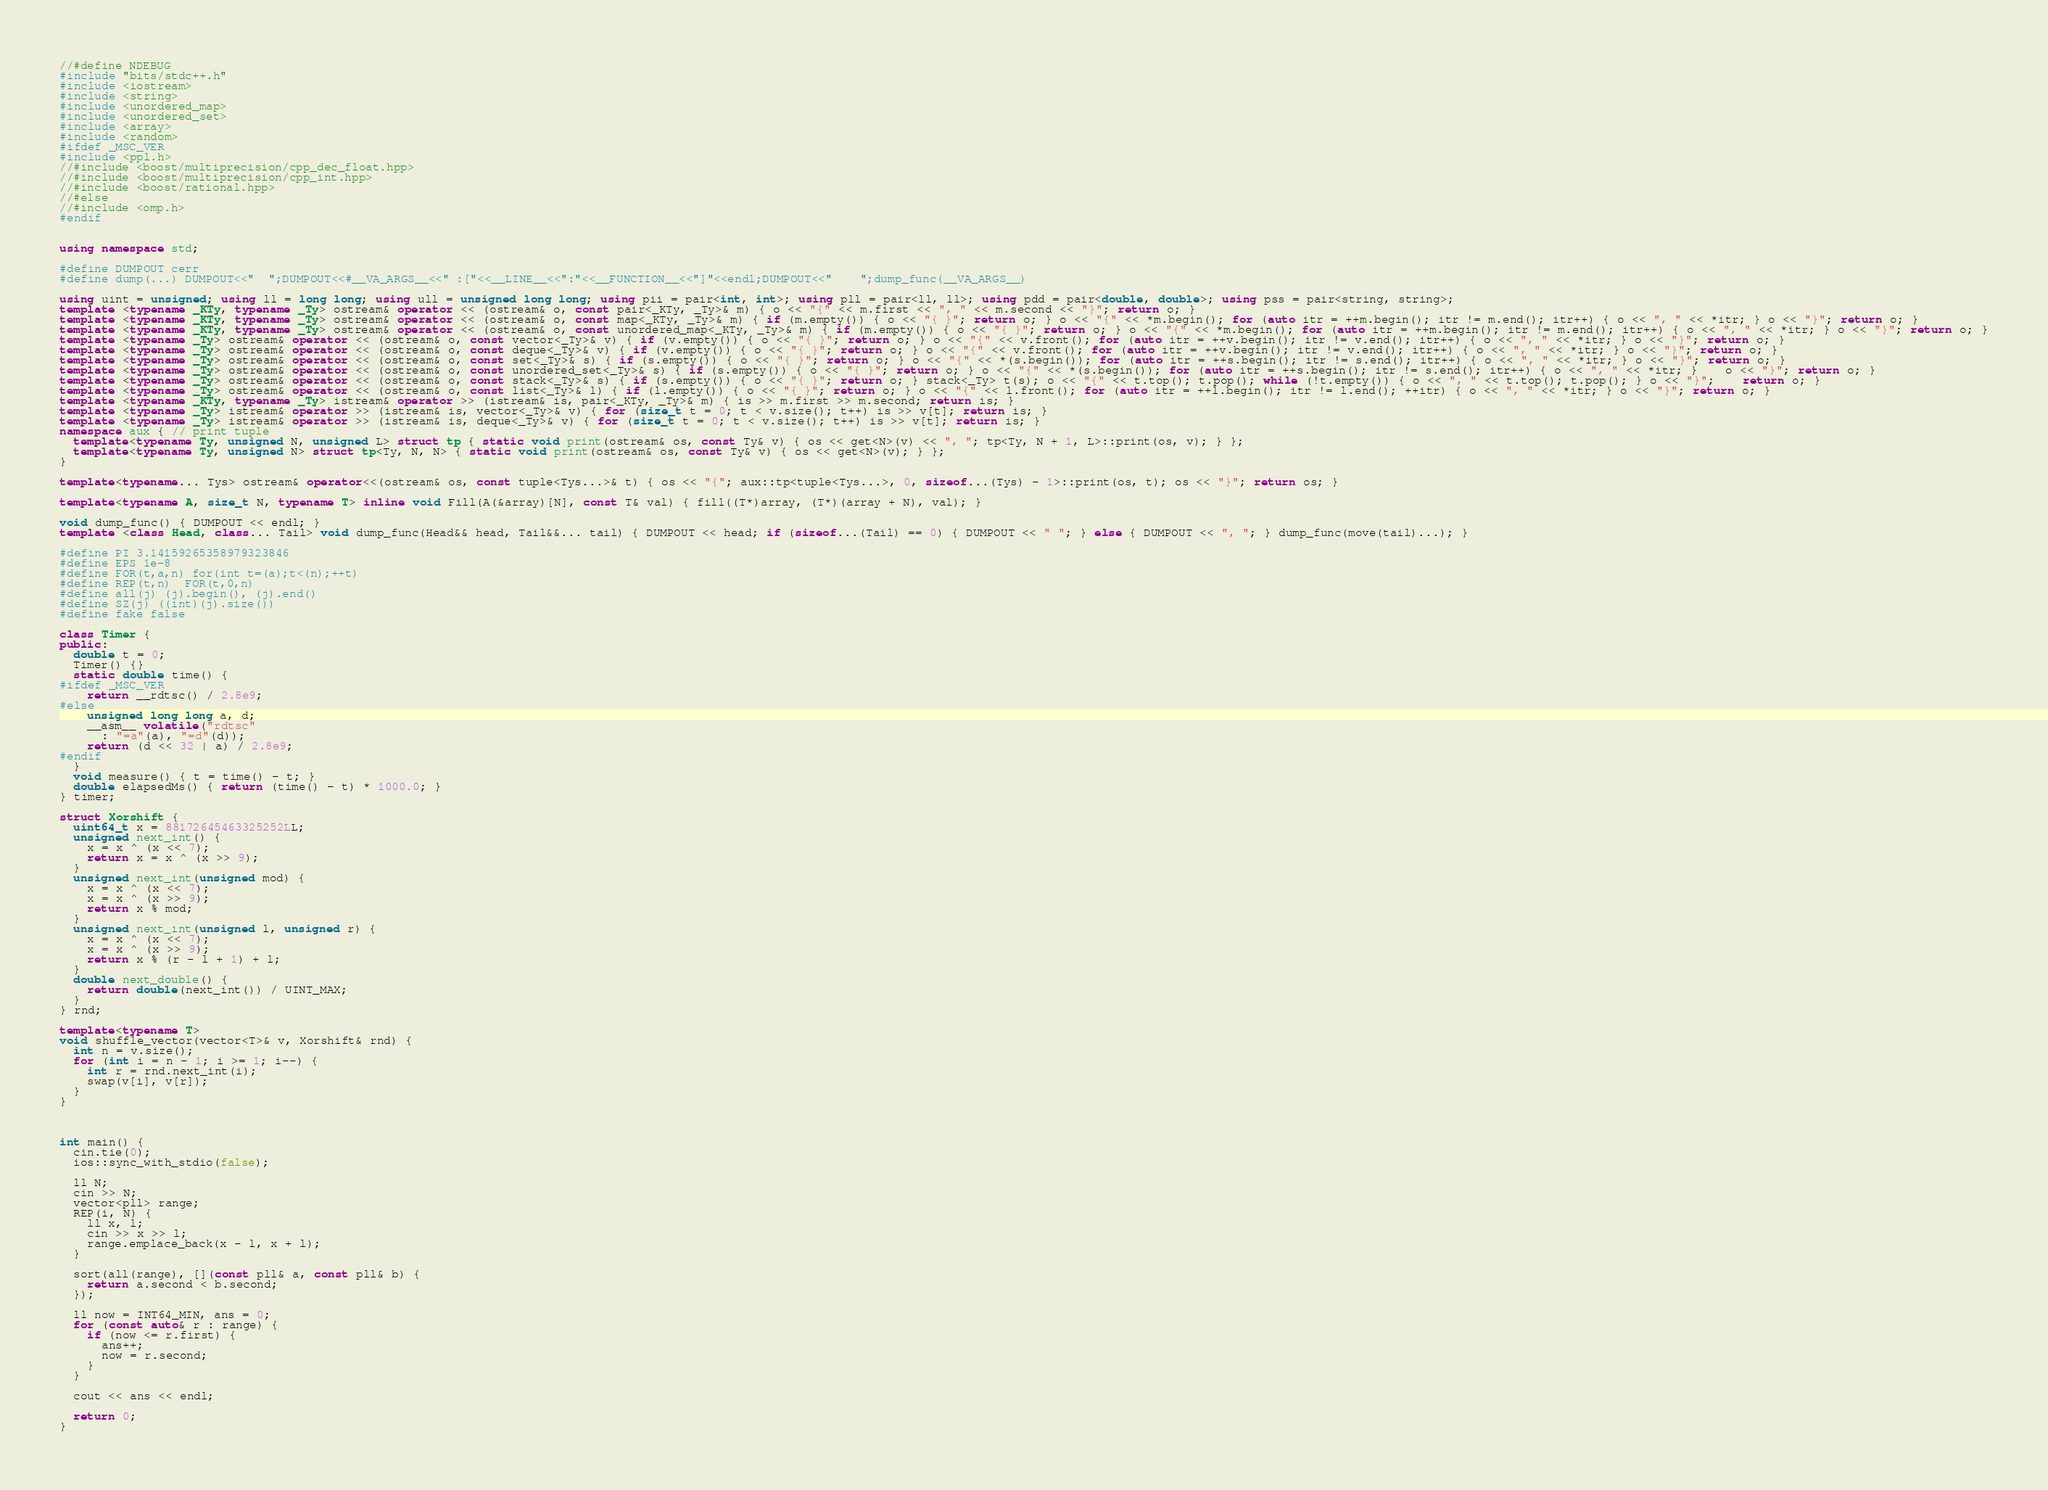<code> <loc_0><loc_0><loc_500><loc_500><_C++_>//#define NDEBUG
#include "bits/stdc++.h"
#include <iostream>
#include <string>
#include <unordered_map>
#include <unordered_set>
#include <array>
#include <random>
#ifdef _MSC_VER
#include <ppl.h>
//#include <boost/multiprecision/cpp_dec_float.hpp>
//#include <boost/multiprecision/cpp_int.hpp>
//#include <boost/rational.hpp>
//#else
//#include <omp.h>
#endif


using namespace std;

#define DUMPOUT cerr
#define dump(...) DUMPOUT<<"  ";DUMPOUT<<#__VA_ARGS__<<" :["<<__LINE__<<":"<<__FUNCTION__<<"]"<<endl;DUMPOUT<<"    ";dump_func(__VA_ARGS__)

using uint = unsigned; using ll = long long; using ull = unsigned long long; using pii = pair<int, int>; using pll = pair<ll, ll>; using pdd = pair<double, double>; using pss = pair<string, string>;
template <typename _KTy, typename _Ty> ostream& operator << (ostream& o, const pair<_KTy, _Ty>& m) { o << "{" << m.first << ", " << m.second << "}"; return o; }
template <typename _KTy, typename _Ty> ostream& operator << (ostream& o, const map<_KTy, _Ty>& m) { if (m.empty()) { o << "{ }"; return o; } o << "{" << *m.begin(); for (auto itr = ++m.begin(); itr != m.end(); itr++) { o << ", " << *itr; } o << "}"; return o; }
template <typename _KTy, typename _Ty> ostream& operator << (ostream& o, const unordered_map<_KTy, _Ty>& m) { if (m.empty()) { o << "{ }"; return o; } o << "{" << *m.begin(); for (auto itr = ++m.begin(); itr != m.end(); itr++) { o << ", " << *itr; } o << "}"; return o; }
template <typename _Ty> ostream& operator << (ostream& o, const vector<_Ty>& v) { if (v.empty()) { o << "{ }"; return o; } o << "{" << v.front(); for (auto itr = ++v.begin(); itr != v.end(); itr++) { o << ", " << *itr; } o << "}"; return o; }
template <typename _Ty> ostream& operator << (ostream& o, const deque<_Ty>& v) { if (v.empty()) { o << "{ }"; return o; } o << "{" << v.front(); for (auto itr = ++v.begin(); itr != v.end(); itr++) { o << ", " << *itr; } o << "}"; return o; }
template <typename _Ty> ostream& operator << (ostream& o, const set<_Ty>& s) { if (s.empty()) { o << "{ }"; return o; } o << "{" << *(s.begin()); for (auto itr = ++s.begin(); itr != s.end(); itr++) { o << ", " << *itr; } o << "}"; return o; }
template <typename _Ty> ostream& operator << (ostream& o, const unordered_set<_Ty>& s) { if (s.empty()) { o << "{ }"; return o; } o << "{" << *(s.begin()); for (auto itr = ++s.begin(); itr != s.end(); itr++) { o << ", " << *itr; }	o << "}"; return o; }
template <typename _Ty> ostream& operator << (ostream& o, const stack<_Ty>& s) { if (s.empty()) { o << "{ }"; return o; } stack<_Ty> t(s); o << "{" << t.top(); t.pop(); while (!t.empty()) { o << ", " << t.top(); t.pop(); } o << "}";	return o; }
template <typename _Ty> ostream& operator << (ostream& o, const list<_Ty>& l) { if (l.empty()) { o << "{ }"; return o; } o << "{" << l.front(); for (auto itr = ++l.begin(); itr != l.end(); ++itr) { o << ", " << *itr; } o << "}"; return o; }
template <typename _KTy, typename _Ty> istream& operator >> (istream& is, pair<_KTy, _Ty>& m) { is >> m.first >> m.second; return is; }
template <typename _Ty> istream& operator >> (istream& is, vector<_Ty>& v) { for (size_t t = 0; t < v.size(); t++) is >> v[t]; return is; }
template <typename _Ty> istream& operator >> (istream& is, deque<_Ty>& v) { for (size_t t = 0; t < v.size(); t++) is >> v[t]; return is; }
namespace aux { // print tuple
  template<typename Ty, unsigned N, unsigned L> struct tp { static void print(ostream& os, const Ty& v) { os << get<N>(v) << ", "; tp<Ty, N + 1, L>::print(os, v); } };
  template<typename Ty, unsigned N> struct tp<Ty, N, N> { static void print(ostream& os, const Ty& v) { os << get<N>(v); } };
}

template<typename... Tys> ostream& operator<<(ostream& os, const tuple<Tys...>& t) { os << "{"; aux::tp<tuple<Tys...>, 0, sizeof...(Tys) - 1>::print(os, t); os << "}"; return os; }

template<typename A, size_t N, typename T> inline void Fill(A(&array)[N], const T& val) { fill((T*)array, (T*)(array + N), val); }

void dump_func() { DUMPOUT << endl; }
template <class Head, class... Tail> void dump_func(Head&& head, Tail&&... tail) { DUMPOUT << head; if (sizeof...(Tail) == 0) { DUMPOUT << " "; } else { DUMPOUT << ", "; } dump_func(move(tail)...); }

#define PI 3.14159265358979323846
#define EPS 1e-8
#define FOR(t,a,n) for(int t=(a);t<(n);++t)
#define REP(t,n)  FOR(t,0,n)
#define all(j) (j).begin(), (j).end()
#define SZ(j) ((int)(j).size())
#define fake false

class Timer {
public:
  double t = 0;
  Timer() {}
  static double time() {
#ifdef _MSC_VER
    return __rdtsc() / 2.8e9;
#else
    unsigned long long a, d;
    __asm__ volatile("rdtsc"
      : "=a"(a), "=d"(d));
    return (d << 32 | a) / 2.8e9;
#endif
  }
  void measure() { t = time() - t; }
  double elapsedMs() { return (time() - t) * 1000.0; }
} timer;

struct Xorshift {
  uint64_t x = 88172645463325252LL;
  unsigned next_int() {
    x = x ^ (x << 7);
    return x = x ^ (x >> 9);
  }
  unsigned next_int(unsigned mod) {
    x = x ^ (x << 7);
    x = x ^ (x >> 9);
    return x % mod;
  }
  unsigned next_int(unsigned l, unsigned r) {
    x = x ^ (x << 7);
    x = x ^ (x >> 9);
    return x % (r - l + 1) + l;
  }
  double next_double() {
    return double(next_int()) / UINT_MAX;
  }
} rnd;

template<typename T>
void shuffle_vector(vector<T>& v, Xorshift& rnd) {
  int n = v.size();
  for (int i = n - 1; i >= 1; i--) {
    int r = rnd.next_int(i);
    swap(v[i], v[r]);
  }
}



int main() {
  cin.tie(0);
  ios::sync_with_stdio(false);

  ll N;
  cin >> N;
  vector<pll> range;
  REP(i, N) {
    ll x, l;
    cin >> x >> l;
    range.emplace_back(x - l, x + l);
  }

  sort(all(range), [](const pll& a, const pll& b) {
    return a.second < b.second;
  });

  ll now = INT64_MIN, ans = 0;
  for (const auto& r : range) {
    if (now <= r.first) {
      ans++;
      now = r.second;
    }
  }

  cout << ans << endl;

  return 0;
}
</code> 